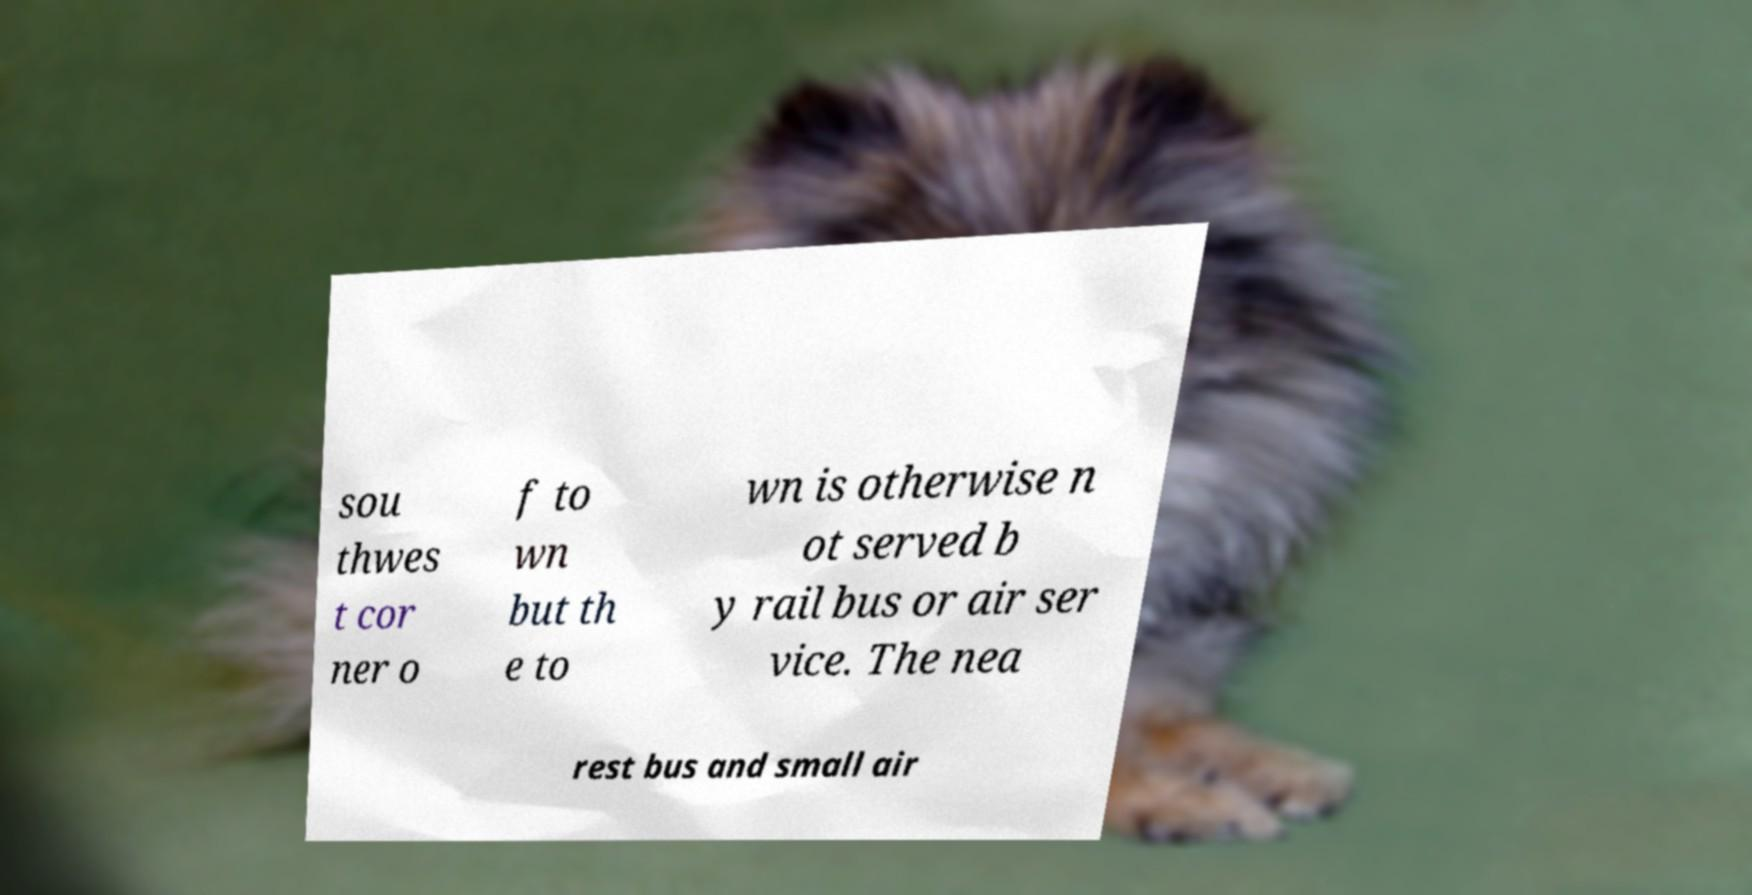What messages or text are displayed in this image? I need them in a readable, typed format. sou thwes t cor ner o f to wn but th e to wn is otherwise n ot served b y rail bus or air ser vice. The nea rest bus and small air 